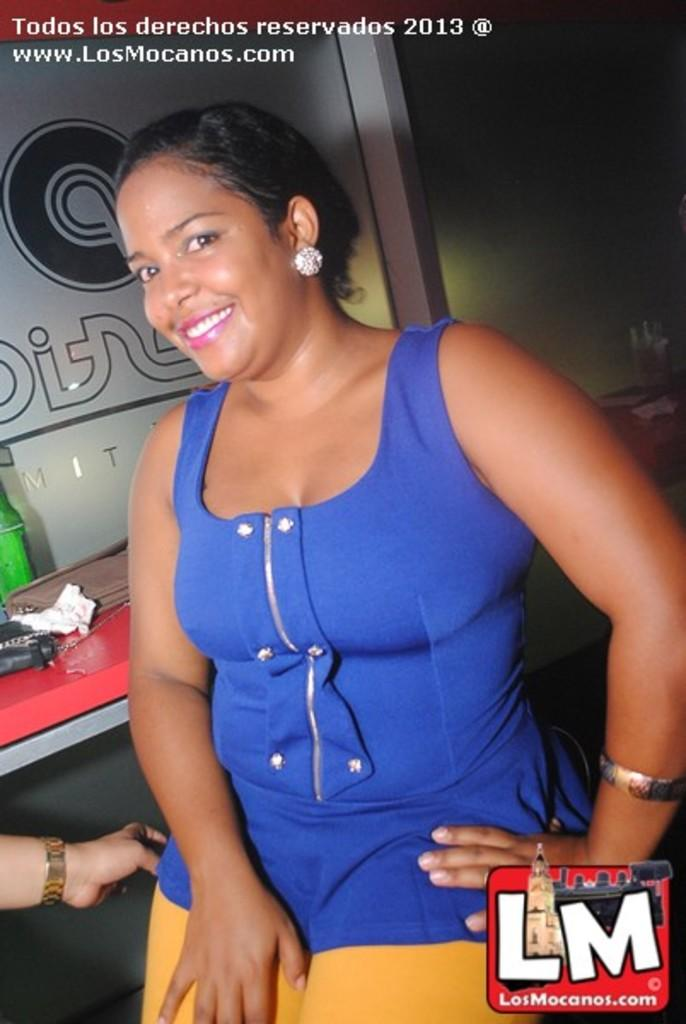<image>
Relay a brief, clear account of the picture shown. A picture of a woman with the website LosMocanos.com advertised in the corner. 